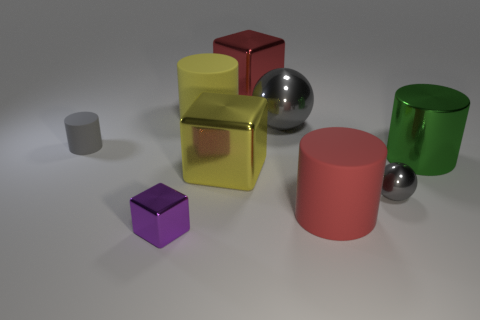What is the size of the red metallic object that is the same shape as the small purple object?
Offer a terse response. Large. What color is the big shiny thing that is the same shape as the small gray rubber thing?
Provide a short and direct response. Green. The other big block that is made of the same material as the red cube is what color?
Your response must be concise. Yellow. There is a red object that is the same shape as the small purple thing; what is it made of?
Offer a very short reply. Metal. How many green cylinders are in front of the big red object behind the rubber thing on the left side of the small metal cube?
Offer a terse response. 1. Are there any other things of the same color as the large sphere?
Your answer should be compact. Yes. How many metal objects are both to the right of the big red block and in front of the small cylinder?
Ensure brevity in your answer.  2. There is a object that is in front of the red cylinder; does it have the same size as the thing that is on the left side of the purple metallic thing?
Ensure brevity in your answer.  Yes. What number of things are either blocks that are in front of the red metallic thing or green objects?
Provide a short and direct response. 3. There is a gray ball that is behind the tiny gray sphere; what is it made of?
Give a very brief answer. Metal. 